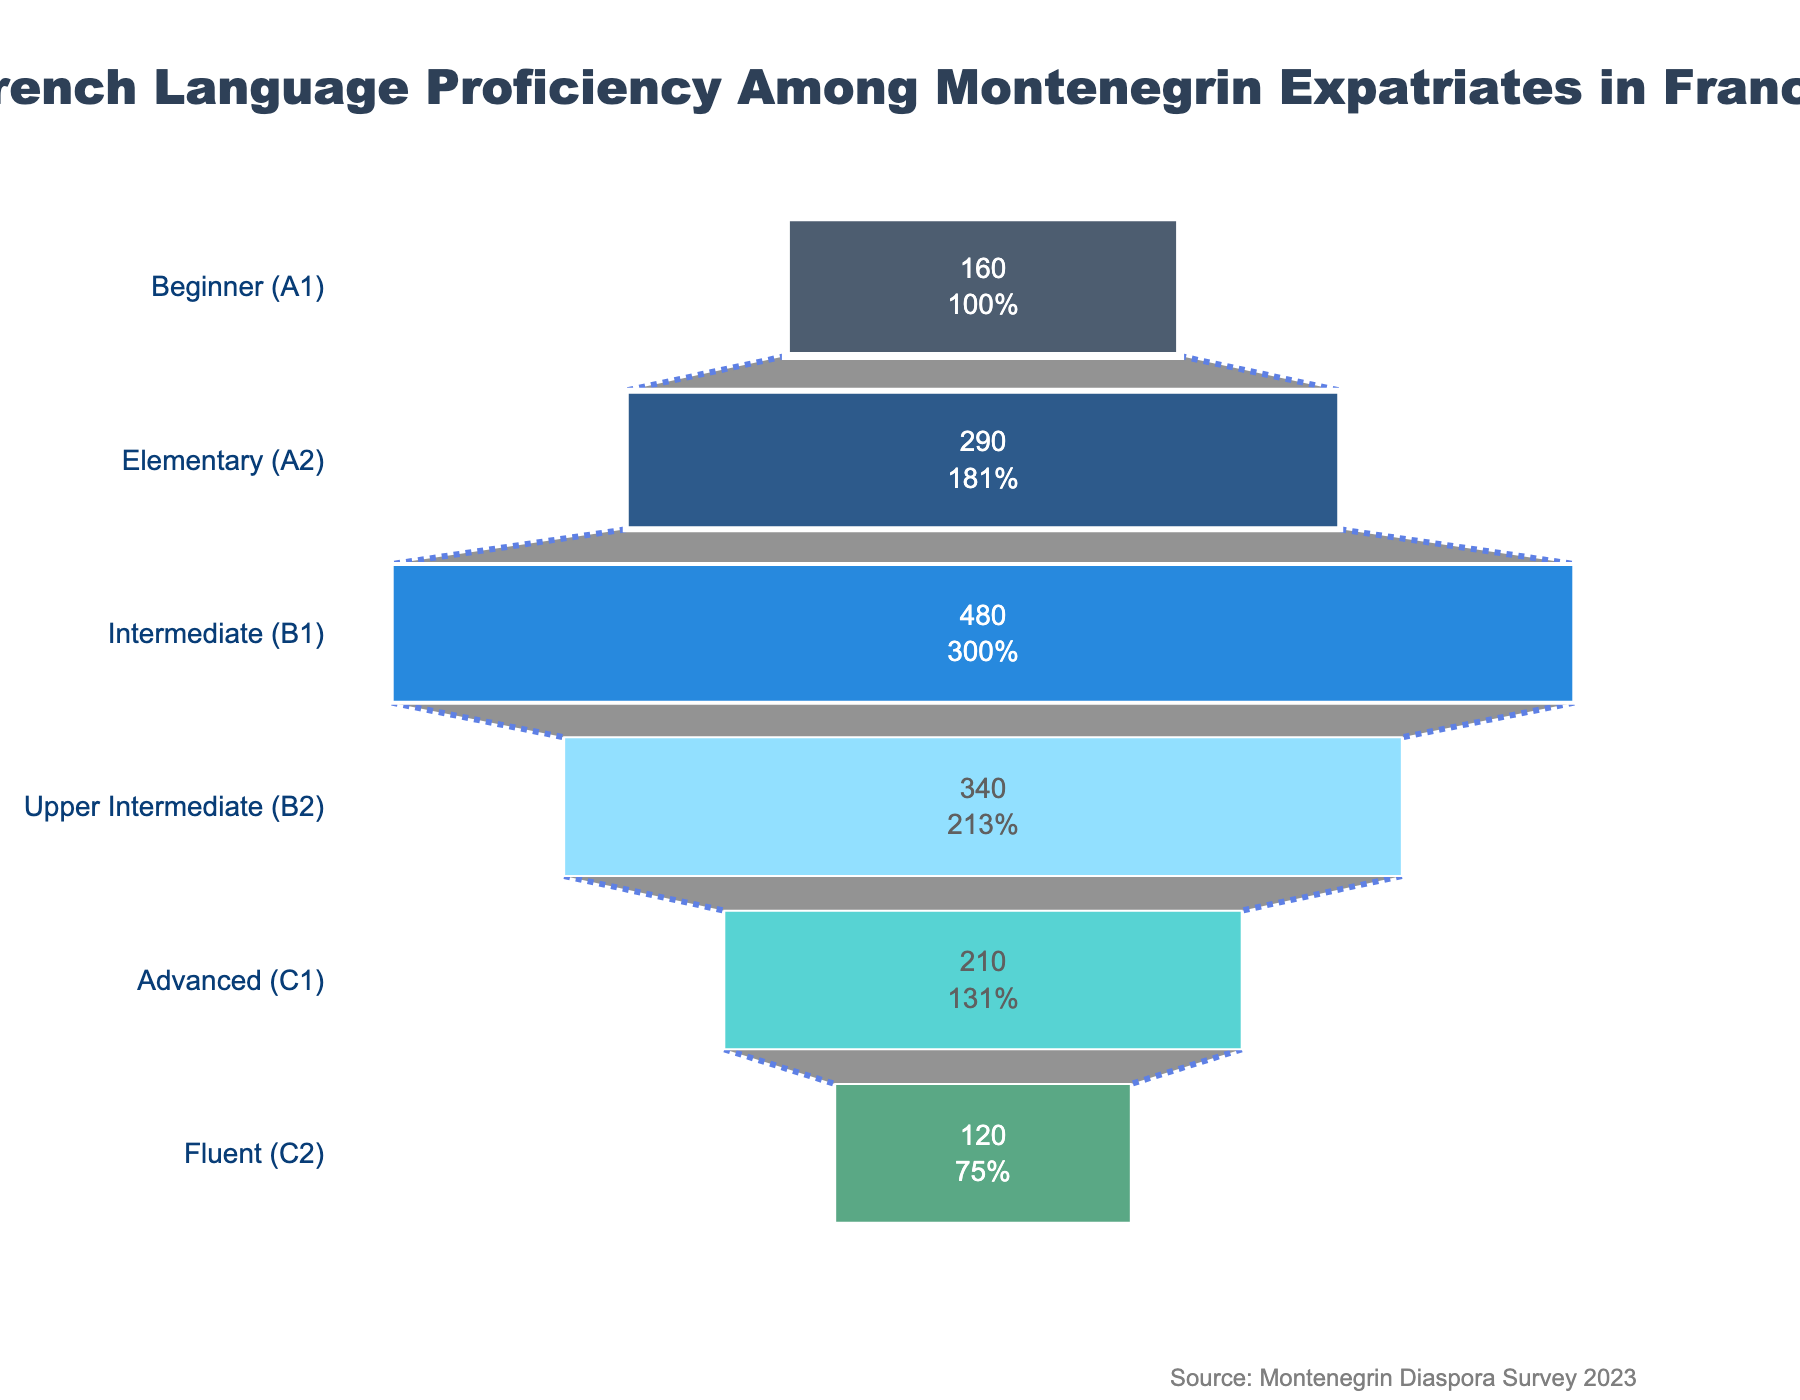How many Montenegrin expatriates have a fluent (C2) proficiency in French? The funnel chart indicates the number of Montenegrin expatriates for each level of French proficiency. For the fluent (C2) level, the chart shows 120 expatriates.
Answer: 120 What percentage of Montenegrin expatriates are at the intermediate (B1) level? The funnel chart shows the number of expatriates at each level and also provides the percentage for each level relative to the initial number (which is 1600 at the beginner level). At the intermediate (B1) level, there are 480 expatriates, which is 30% of the initial number.
Answer: 30% Which proficiency level has the highest number of Montenegrin expatriates? By looking at the funnel chart, the level with the highest number of expatriates can be identified by observing the widest part of the chart. The intermediate (B1) level has the highest number, with 480 expatriates.
Answer: Intermediate (B1) By how much does the number of advanced (C1) level expatriates differ from the number of elementary (A2) level expatriates? The chart shows that there are 210 expatriates at the advanced (C1) level and 290 at the elementary (A2) level. The difference can be calculated as 290 - 210 = 80.
Answer: 80 What is the total number of Montenegrin expatriates above the upper intermediate level (B2)? Adding the numbers above the B2 level from the chart: fluent (C2) is 120 and advanced (C1) is 210. The total number is 120 + 210 = 330.
Answer: 330 Is the number of expatriates at the beginner (A1) level greater than the number at the upper intermediate (B2) level? By comparing both levels from the chart, we see that there are 160 expatriates at the beginner (A1) level and 340 expatriates at the upper intermediate (B2) level. 160 is less than 340, so no.
Answer: No What is the proportion of expatriates at the elementary (A2) level to the total number of expatriates shown in the chart? The elementary (A2) level has 290 expatriates. The total number of expatriates, summing all levels, is 120 (C2) + 210 (C1) + 340 (B2) + 480 (B1) + 290 (A2) + 160 (A1) = 1600. The proportion is 290 / 1600 = 0.18125, or 18.125%.
Answer: 18.125% What is the difference between the number of intermediates (B1) Montenegrin expatriates and the total number of expatriates at the advanced (C1) and fluent (C2) levels combined? The number of intermediates (B1) expatriates is 480. The total number for advanced (C1) and fluent (C2) levels combined is 210 + 120 = 330. The difference is 480 - 330 = 150.
Answer: 150 